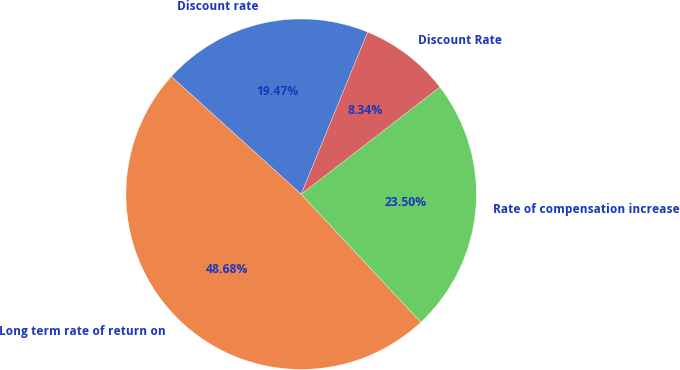Convert chart. <chart><loc_0><loc_0><loc_500><loc_500><pie_chart><fcel>Discount rate<fcel>Long term rate of return on<fcel>Rate of compensation increase<fcel>Discount Rate<nl><fcel>19.47%<fcel>48.68%<fcel>23.5%<fcel>8.34%<nl></chart> 